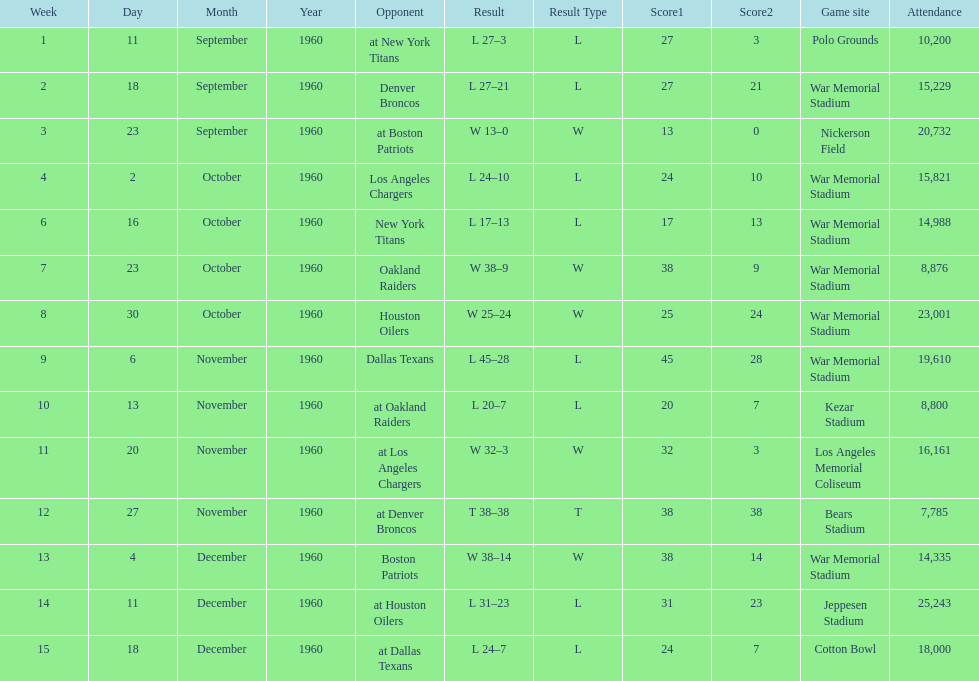How many games had an attendance of 10,000 at most? 11. 